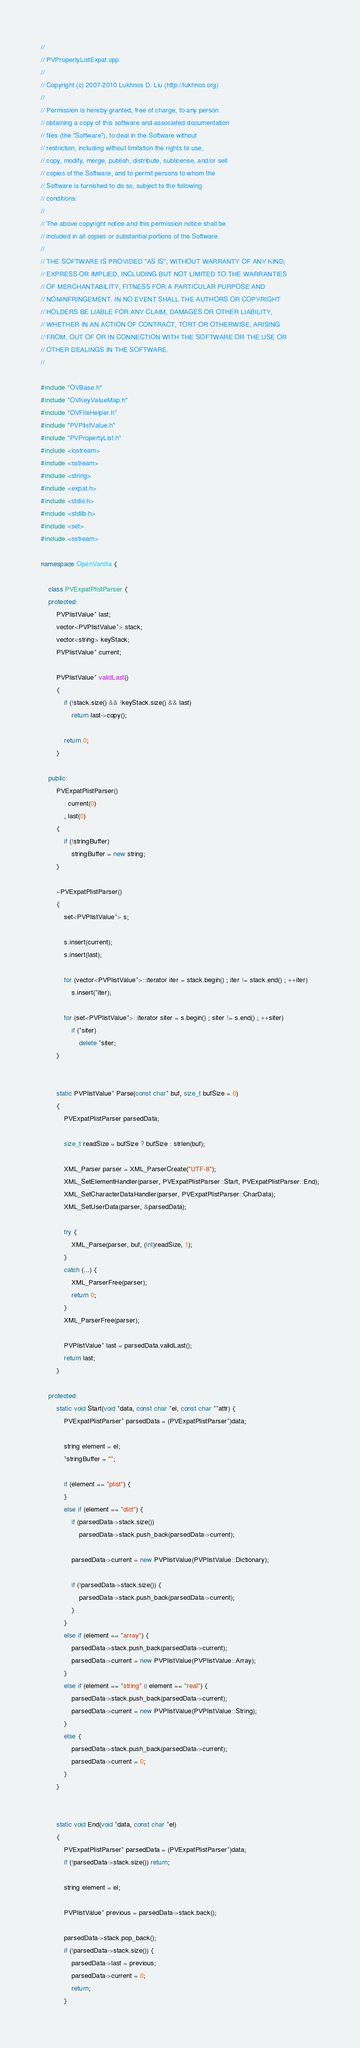<code> <loc_0><loc_0><loc_500><loc_500><_C++_>//
// PVPropertyListExpat.cpp
//
// Copyright (c) 2007-2010 Lukhnos D. Liu (http://lukhnos.org)
//
// Permission is hereby granted, free of charge, to any person
// obtaining a copy of this software and associated documentation
// files (the "Software"), to deal in the Software without
// restriction, including without limitation the rights to use,
// copy, modify, merge, publish, distribute, sublicense, and/or sell
// copies of the Software, and to permit persons to whom the
// Software is furnished to do so, subject to the following
// conditions:
//
// The above copyright notice and this permission notice shall be
// included in all copies or substantial portions of the Software.
//
// THE SOFTWARE IS PROVIDED "AS IS", WITHOUT WARRANTY OF ANY KIND,
// EXPRESS OR IMPLIED, INCLUDING BUT NOT LIMITED TO THE WARRANTIES
// OF MERCHANTABILITY, FITNESS FOR A PARTICULAR PURPOSE AND
// NONINFRINGEMENT. IN NO EVENT SHALL THE AUTHORS OR COPYRIGHT
// HOLDERS BE LIABLE FOR ANY CLAIM, DAMAGES OR OTHER LIABILITY,
// WHETHER IN AN ACTION OF CONTRACT, TORT OR OTHERWISE, ARISING
// FROM, OUT OF OR IN CONNECTION WITH THE SOFTWARE OR THE USE OR
// OTHER DEALINGS IN THE SOFTWARE.
//

#include "OVBase.h"
#include "OVKeyValueMap.h"
#include "OVFileHelper.h"
#include "PVPlistValue.h"
#include "PVPropertyList.h"
#include <iostream>
#include <sstream>
#include <string>
#include <expat.h>
#include <stdio.h>
#include <stdlib.h>
#include <set>
#include <sstream>

namespace OpenVanilla {

    class PVExpatPlistParser {
    protected:
        PVPlistValue* last;
        vector<PVPlistValue*> stack;
        vector<string> keyStack;
        PVPlistValue* current;
        
        PVPlistValue* validLast()
        {
            if (!stack.size() && !keyStack.size() && last)
                return last->copy();

            return 0;
        }

    public:
        PVExpatPlistParser()
            : current(0)
            , last(0)
        {
            if (!stringBuffer)
                stringBuffer = new string;
        }

        ~PVExpatPlistParser()
        {
            set<PVPlistValue*> s;

            s.insert(current);
            s.insert(last);
            
            for (vector<PVPlistValue*>::iterator iter = stack.begin() ; iter != stack.end() ; ++iter)
                s.insert(*iter);

            for (set<PVPlistValue*>::iterator siter = s.begin() ; siter != s.end() ; ++siter)
                if (*siter)
                    delete *siter;
        }
        

        static PVPlistValue* Parse(const char* buf, size_t bufSize = 0)
        {
            PVExpatPlistParser parsedData;
            
            size_t readSize = bufSize ? bufSize : strlen(buf);

            XML_Parser parser = XML_ParserCreate("UTF-8");
            XML_SetElementHandler(parser, PVExpatPlistParser::Start, PVExpatPlistParser::End);
            XML_SetCharacterDataHandler(parser, PVExpatPlistParser::CharData);
            XML_SetUserData(parser, &parsedData);

			try {
				XML_Parse(parser, buf, (int)readSize, 1);
			}
			catch (...) {
				XML_ParserFree(parser);
				return 0;
			}
            XML_ParserFree(parser);
            
            PVPlistValue* last = parsedData.validLast();        
            return last;
        }
            
    protected:
        static void Start(void *data, const char *el, const char **attr) {
            PVExpatPlistParser* parsedData = (PVExpatPlistParser*)data;

            string element = el;
            *stringBuffer = "";

            if (element == "plist") {
            }
            else if (element == "dict") {
                if (parsedData->stack.size())
                    parsedData->stack.push_back(parsedData->current);
                    
                parsedData->current = new PVPlistValue(PVPlistValue::Dictionary);

                if (!parsedData->stack.size()) {
                    parsedData->stack.push_back(parsedData->current);
                }
            }
            else if (element == "array") {
                parsedData->stack.push_back(parsedData->current);            
                parsedData->current = new PVPlistValue(PVPlistValue::Array);
            }    
            else if (element == "string" || element == "real") {
                parsedData->stack.push_back(parsedData->current);            
                parsedData->current = new PVPlistValue(PVPlistValue::String);
            }
            else {
                parsedData->stack.push_back(parsedData->current);
                parsedData->current = 0;
            }
        }
        
        
        static void End(void *data, const char *el)
        {            
            PVExpatPlistParser* parsedData = (PVExpatPlistParser*)data;
            if (!parsedData->stack.size()) return;

            string element = el;

            PVPlistValue* previous = parsedData->stack.back();
            
            parsedData->stack.pop_back();
            if (!parsedData->stack.size()) {
                parsedData->last = previous;                
                parsedData->current = 0;
                return;
            }</code> 